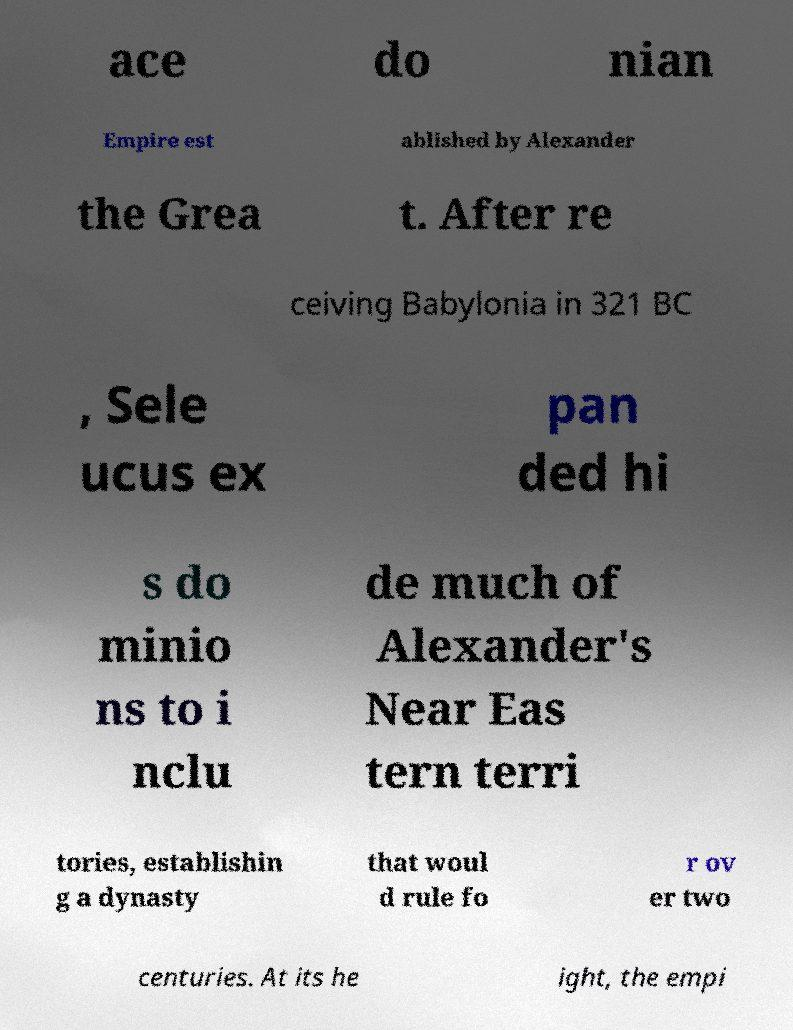Could you assist in decoding the text presented in this image and type it out clearly? ace do nian Empire est ablished by Alexander the Grea t. After re ceiving Babylonia in 321 BC , Sele ucus ex pan ded hi s do minio ns to i nclu de much of Alexander's Near Eas tern terri tories, establishin g a dynasty that woul d rule fo r ov er two centuries. At its he ight, the empi 